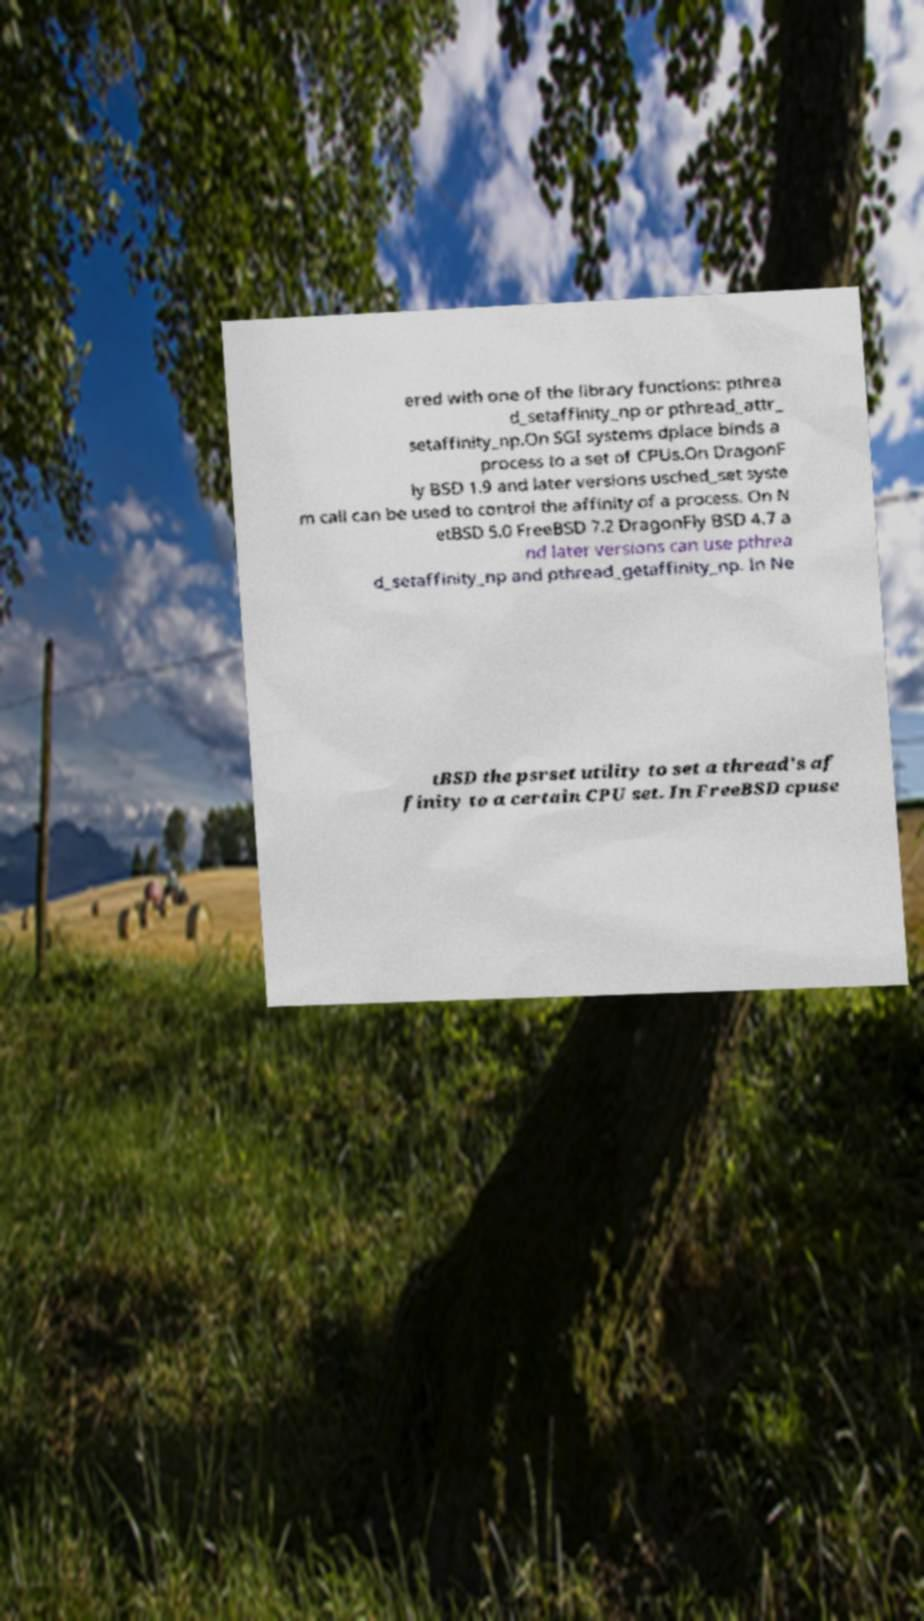For documentation purposes, I need the text within this image transcribed. Could you provide that? ered with one of the library functions: pthrea d_setaffinity_np or pthread_attr_ setaffinity_np.On SGI systems dplace binds a process to a set of CPUs.On DragonF ly BSD 1.9 and later versions usched_set syste m call can be used to control the affinity of a process. On N etBSD 5.0 FreeBSD 7.2 DragonFly BSD 4.7 a nd later versions can use pthrea d_setaffinity_np and pthread_getaffinity_np. In Ne tBSD the psrset utility to set a thread's af finity to a certain CPU set. In FreeBSD cpuse 